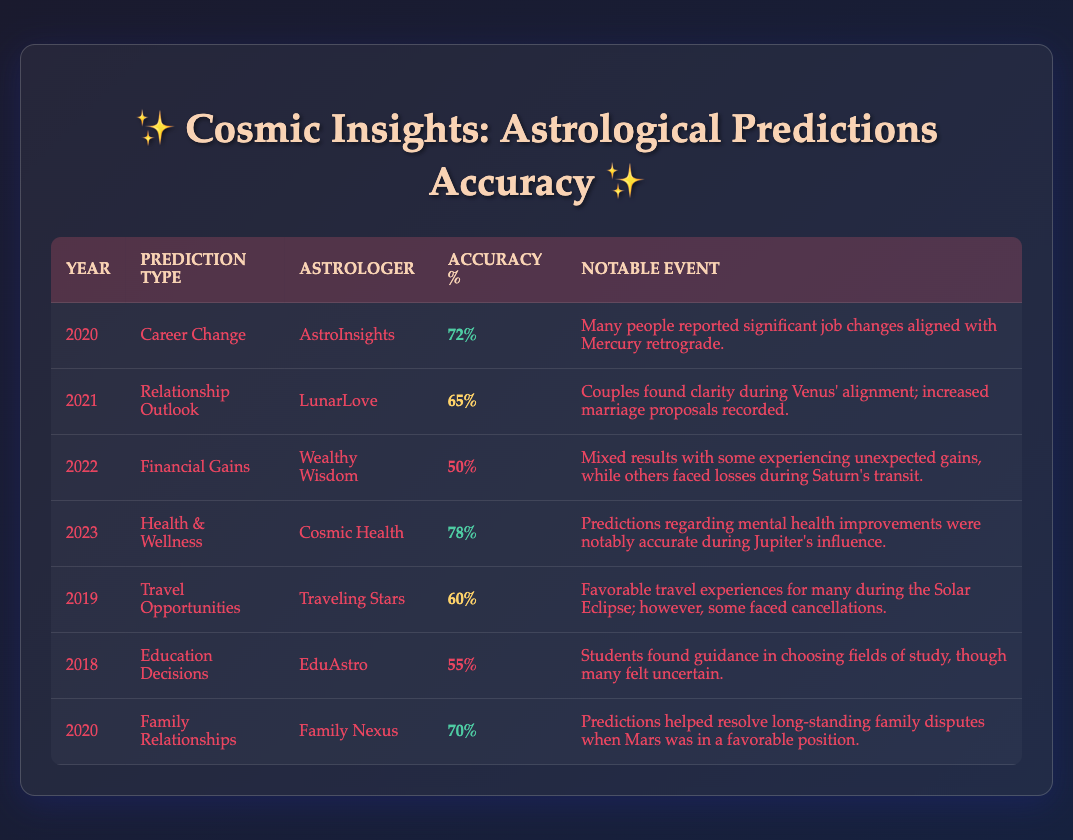What was the highest accuracy percentage in the predictions? The highest accuracy percentage in the table is 78%, which is for the prediction type "Health & Wellness" made by "Cosmic Health" in 2023.
Answer: 78% Which astrologer had the highest accuracy in predictions for 2020? In 2020, "AstroInsights" for "Career Change" had an accuracy of 72%, while "Family Nexus" for "Family Relationships" had 70%. Since both were in 2020, the highest is "AstroInsights".
Answer: AstroInsights What was the average accuracy percentage for the predictions in 2021 and 2022? In 2021, the accuracy was 65%, and in 2022, it was 50%. Adding these gives 65 + 50 = 115 and dividing by 2 gives an average of 57.5.
Answer: 57.5% Did any predictions in 2018 have an accuracy of 60% or higher? The only prediction from 2018 was "Education Decisions" by "EduAstro", which had an accuracy of 55%, thus no predictions met the criteria.
Answer: No Which prediction type had the lowest accuracy percentage? The "Financial Gains" prediction in 2022 had the lowest accuracy at 50%.
Answer: Financial Gains Which year had a notable event regarding mental health improvements? The year 2023 had the notable event regarding mental health improvements during Jupiter's influence, in the category of "Health & Wellness".
Answer: 2023 How many prediction types had an accuracy percentage above 70%? From the table, there are three predictions (2020 Career Change, 2023 Health & Wellness, and 2020 Family Relationships) with accuracy percentages above 70% (72%, 78%, and 70% respectively).
Answer: 3 What percentage accuracy did "LunarLove" achieve for relationship outlook in 2021? "LunarLove" achieved an accuracy of 65% for the prediction type "Relationship Outlook" in 2021.
Answer: 65% Is there a prediction type that occurred in both 2020 and 2023? Yes, "Career Change" was predicted in 2020 with 72% accuracy, while 2023 had "Health & Wellness" with 78% accuracy. There is only overlap in years but different event types.
Answer: No If you sum the accuracy percentages of the predictions made by "Cosmic Health" and "LunarLove," what do you get? "Cosmic Health" (2023) had an accuracy of 78%, and "LunarLove" (2021) had 65%. Adding them gives 78 + 65 = 143.
Answer: 143 